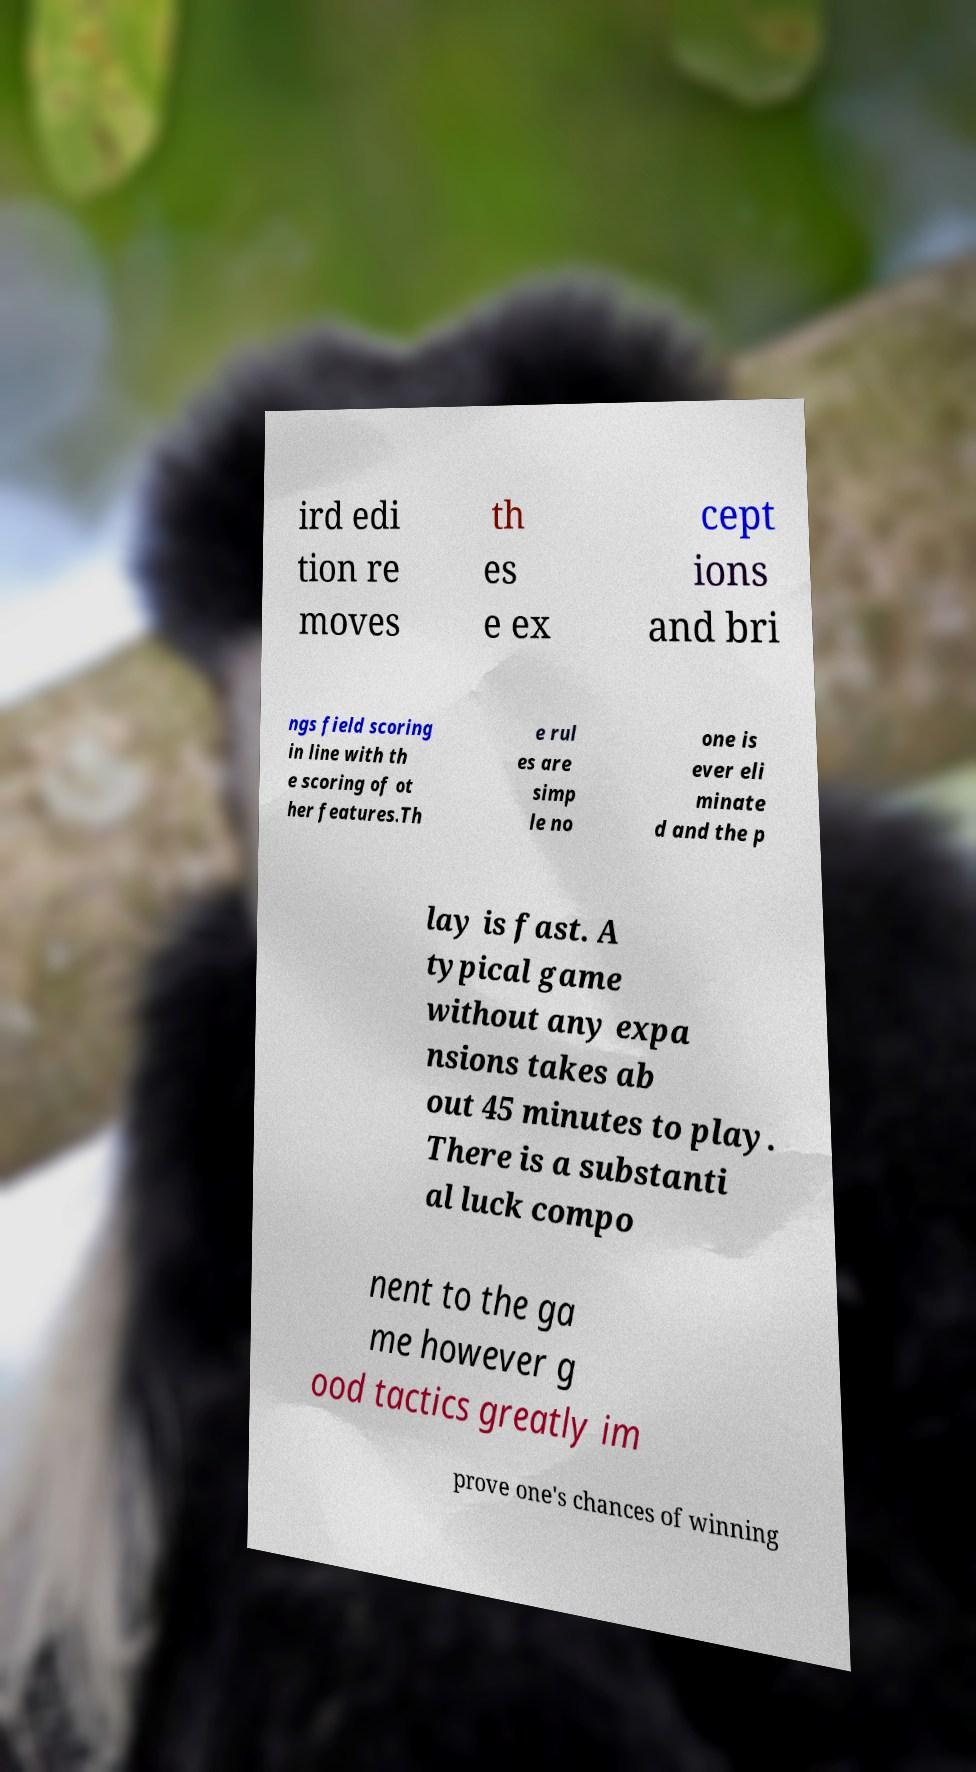Could you assist in decoding the text presented in this image and type it out clearly? ird edi tion re moves th es e ex cept ions and bri ngs field scoring in line with th e scoring of ot her features.Th e rul es are simp le no one is ever eli minate d and the p lay is fast. A typical game without any expa nsions takes ab out 45 minutes to play. There is a substanti al luck compo nent to the ga me however g ood tactics greatly im prove one's chances of winning 